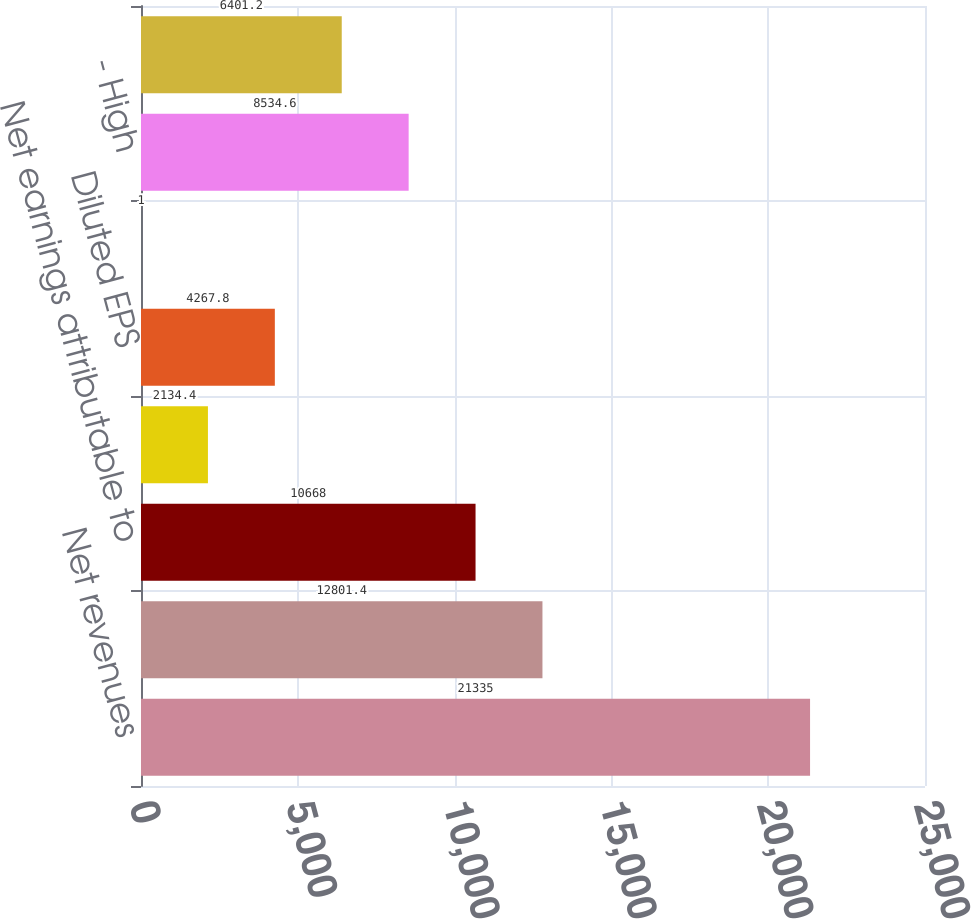Convert chart. <chart><loc_0><loc_0><loc_500><loc_500><bar_chart><fcel>Net revenues<fcel>Gross profit<fcel>Net earnings attributable to<fcel>Basic EPS<fcel>Diluted EPS<fcel>Dividends declared<fcel>- High<fcel>- Low<nl><fcel>21335<fcel>12801.4<fcel>10668<fcel>2134.4<fcel>4267.8<fcel>1<fcel>8534.6<fcel>6401.2<nl></chart> 